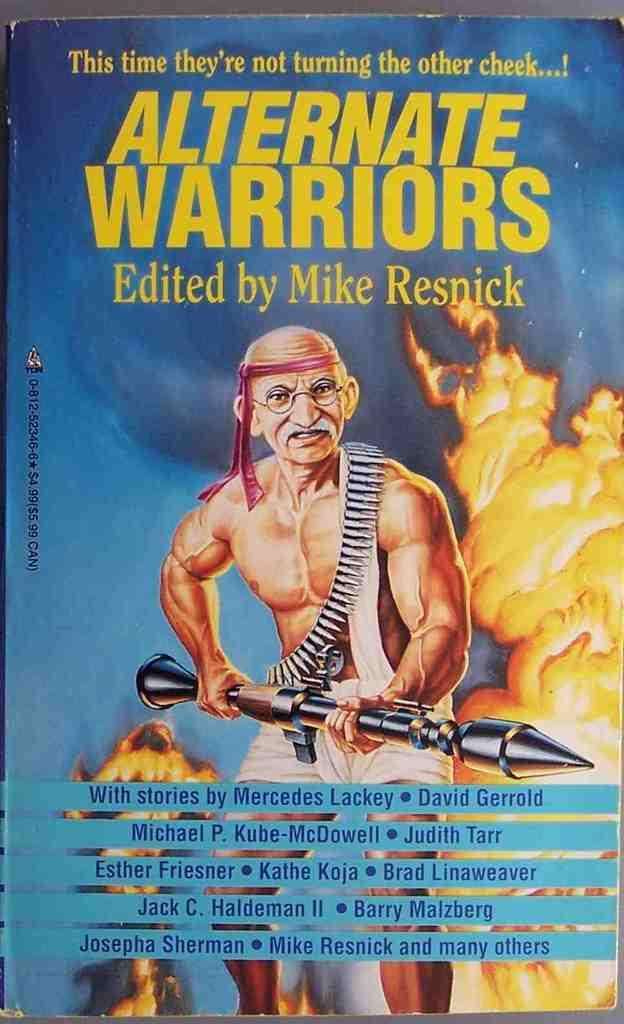What is present in the image? There is a person in the image. What is the person holding? The person is holding an object. Can you describe the book in the image? There is text written on a book in the image. What can be seen in the image besides the person and the book? There is fire in the image. What type of jam is being spread on the pizzas in the image? There are no pizzas or jam present in the image. What type of brush is being used to paint the fire in the image? There is no brush present in the image, and the fire is not being painted. 